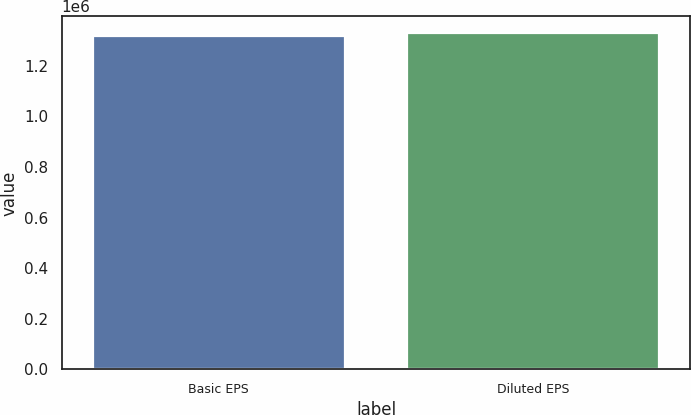Convert chart. <chart><loc_0><loc_0><loc_500><loc_500><bar_chart><fcel>Basic EPS<fcel>Diluted EPS<nl><fcel>1.31763e+06<fcel>1.328e+06<nl></chart> 